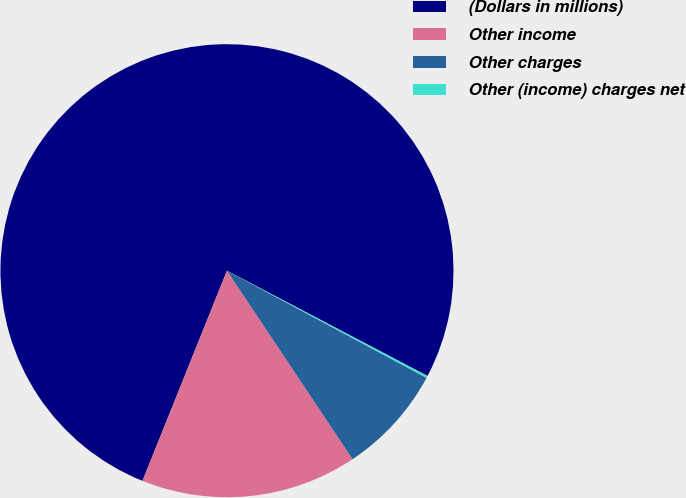Convert chart. <chart><loc_0><loc_0><loc_500><loc_500><pie_chart><fcel>(Dollars in millions)<fcel>Other income<fcel>Other charges<fcel>Other (income) charges net<nl><fcel>76.61%<fcel>15.44%<fcel>7.8%<fcel>0.15%<nl></chart> 